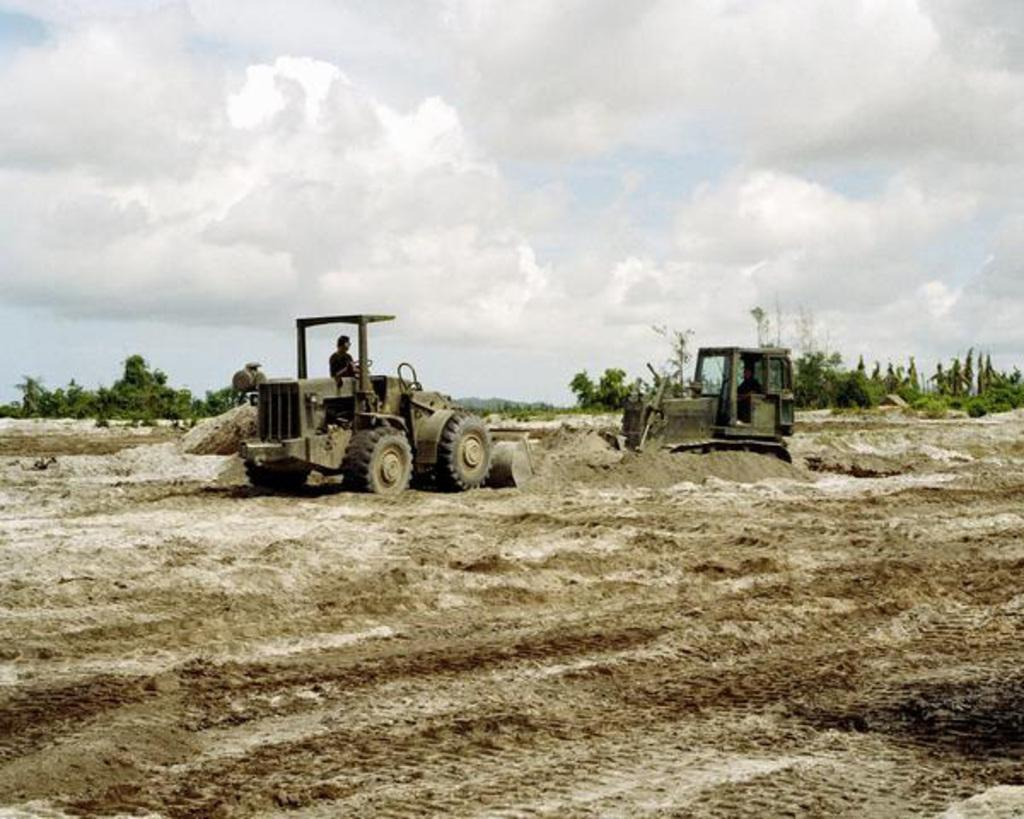How many people are in the image? There are two people in the image. What are the people doing in the image? The people are sitting and riding vehicles. What can be seen in the background of the image? There are trees and the sky visible in the background of the image. What is the condition of the sky in the image? Clouds are present in the sky. What type of humor can be seen in the man's expression in the image? There is no man present in the image, and therefore no expression to analyze for humor. 